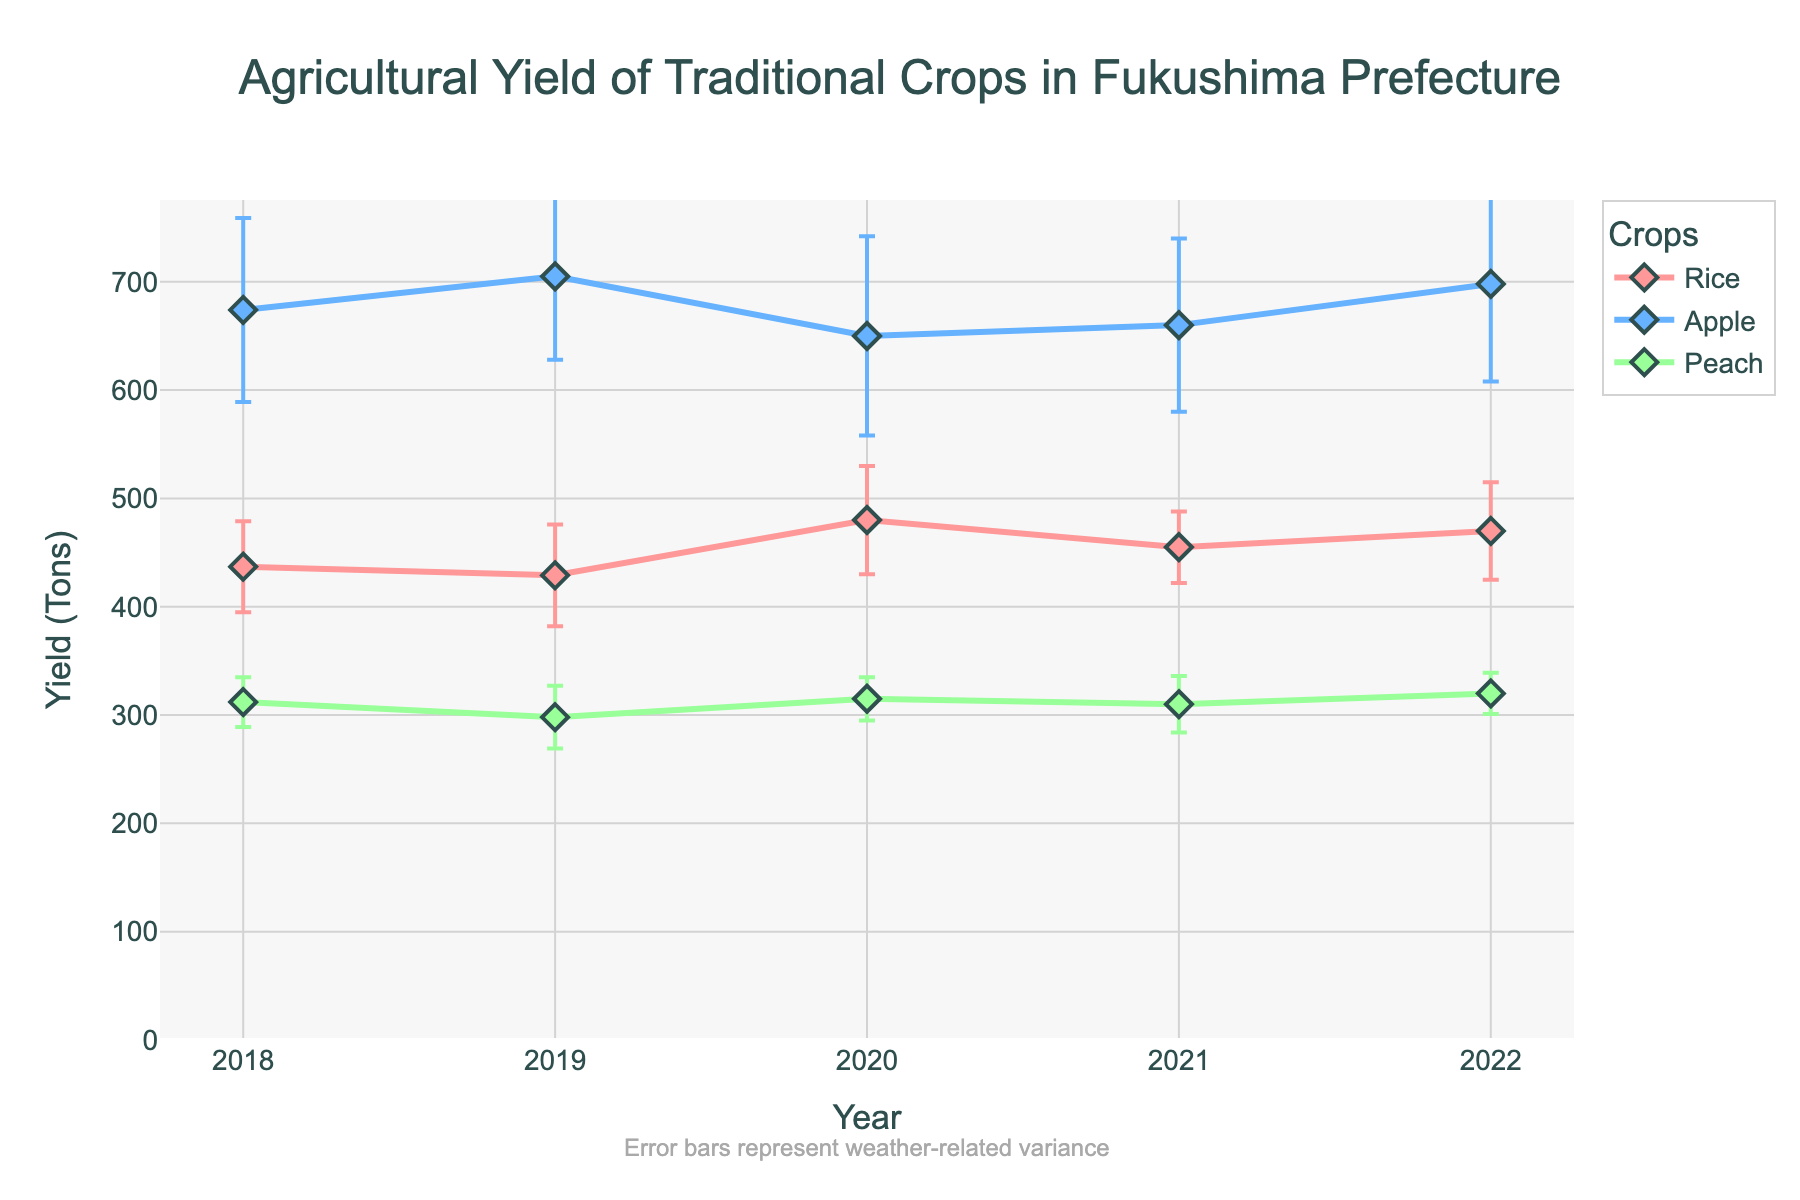What's the title of the plot? The title is found at the top of the plot. It provides an overview of what the plot represents.
Answer: Agricultural Yield of Traditional Crops in Fukushima Prefecture What information is shown on the y-axis? The label on the y-axis indicates what is being measured. It shows the unit of measurement for the data presented.
Answer: Yield (Tons) How many different crops are shown in the plot? By observing the legend on the plot, you can see the distinct colors or markers representing each crop.
Answer: Three Which crop had the highest yield in 2022? Look for the yield values for each crop in 2022 and compare them to find the highest one.
Answer: Apple What was the peach yield in 2019? By locating the data point for peach corresponding to 2019 on the plot, you can find the yield value.
Answer: 298 tons How do the error bars for apple in 2020 compare to those for rice in the same year? Observe the length of the error bars for both crops in the year 2020 and compare their sizes.
Answer: Apple has longer error bars than rice What is the average yield of rice over the years? Add up the rice yields from each year (437+429+480+455+470) and divide by the number of years (5).
Answer: 454.2 tons Which year had the smallest yield variance among all crops and what was the crop? Identify the year and the crop where the error bars are the shortest, indicating the smallest yield variance.
Answer: 2022 for Peach In which year did rice experience the highest weather-related variance? Look at the length of the error bars for rice across all years and identify the year with the longest error bar.
Answer: 2020 Did the yield of apples generally increase or decrease from 2018 to 2022? Observe the trend of the apple yield points from 2018 to 2022 to identify if it shows an increasing or decreasing pattern.
Answer: Increase 